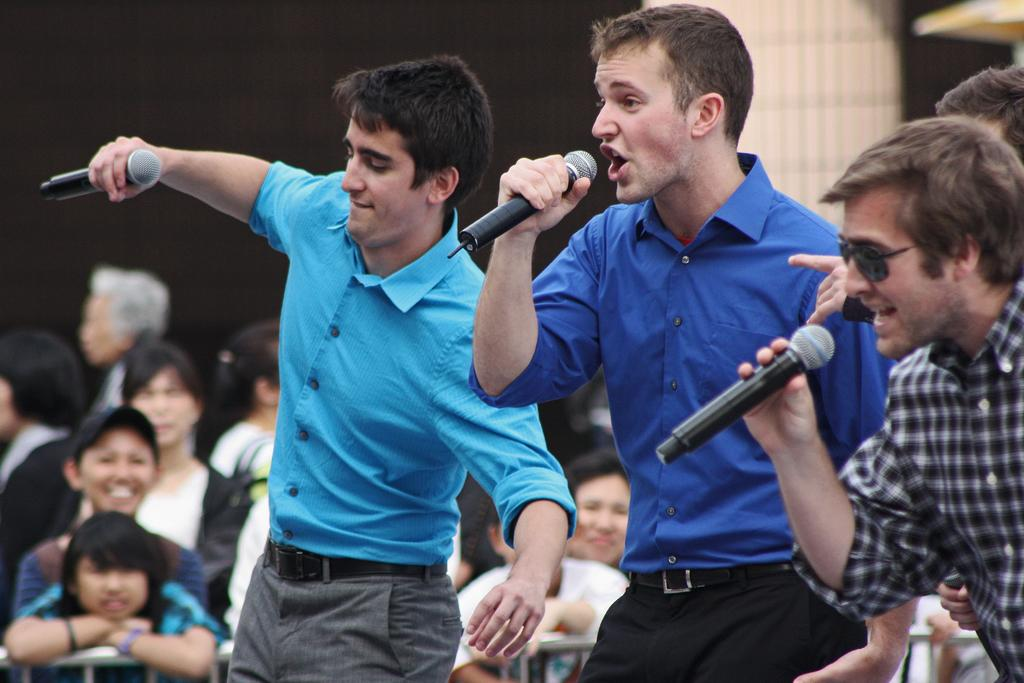What are the people in the image doing? There are people standing in the image, and some of them are holding microphones. Can you describe the people in the background? In the background, there are people standing, and they appear to be watching a show. What might the people holding microphones be doing? The people holding microphones might be performing or speaking during the show. What color is the fork being used by the expert in the image? There is no fork or expert present in the image. 